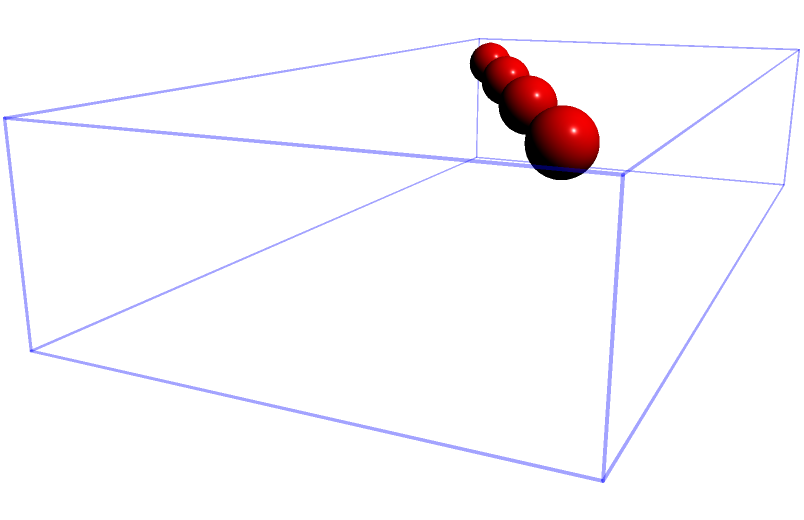In a synchronized swimming routine, four swimmers form a diagonal line across a pool that measures 10m long, 5m wide, and 2m deep. Each swimmer displaces an average volume of 0.065 m³ when submerged. If the routine requires all swimmers to be fully submerged simultaneously, what percentage of the pool's total volume is displaced by the swimmers? To solve this problem, we'll follow these steps:

1. Calculate the total volume of the pool:
   $V_{pool} = length \times width \times depth$
   $V_{pool} = 10\text{ m} \times 5\text{ m} \times 2\text{ m} = 100\text{ m}^3$

2. Calculate the total volume displaced by the swimmers:
   $V_{swimmers} = number\text{ of swimmers} \times volume\text{ displaced per swimmer}$
   $V_{swimmers} = 4 \times 0.065\text{ m}^3 = 0.26\text{ m}^3$

3. Calculate the percentage of the pool's volume displaced:
   $Percentage = \frac{V_{swimmers}}{V_{pool}} \times 100\%$
   $Percentage = \frac{0.26\text{ m}^3}{100\text{ m}^3} \times 100\% = 0.26\%$

Therefore, the swimmers displace 0.26% of the pool's total volume when fully submerged.
Answer: 0.26% 